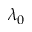<formula> <loc_0><loc_0><loc_500><loc_500>\lambda _ { 0 }</formula> 